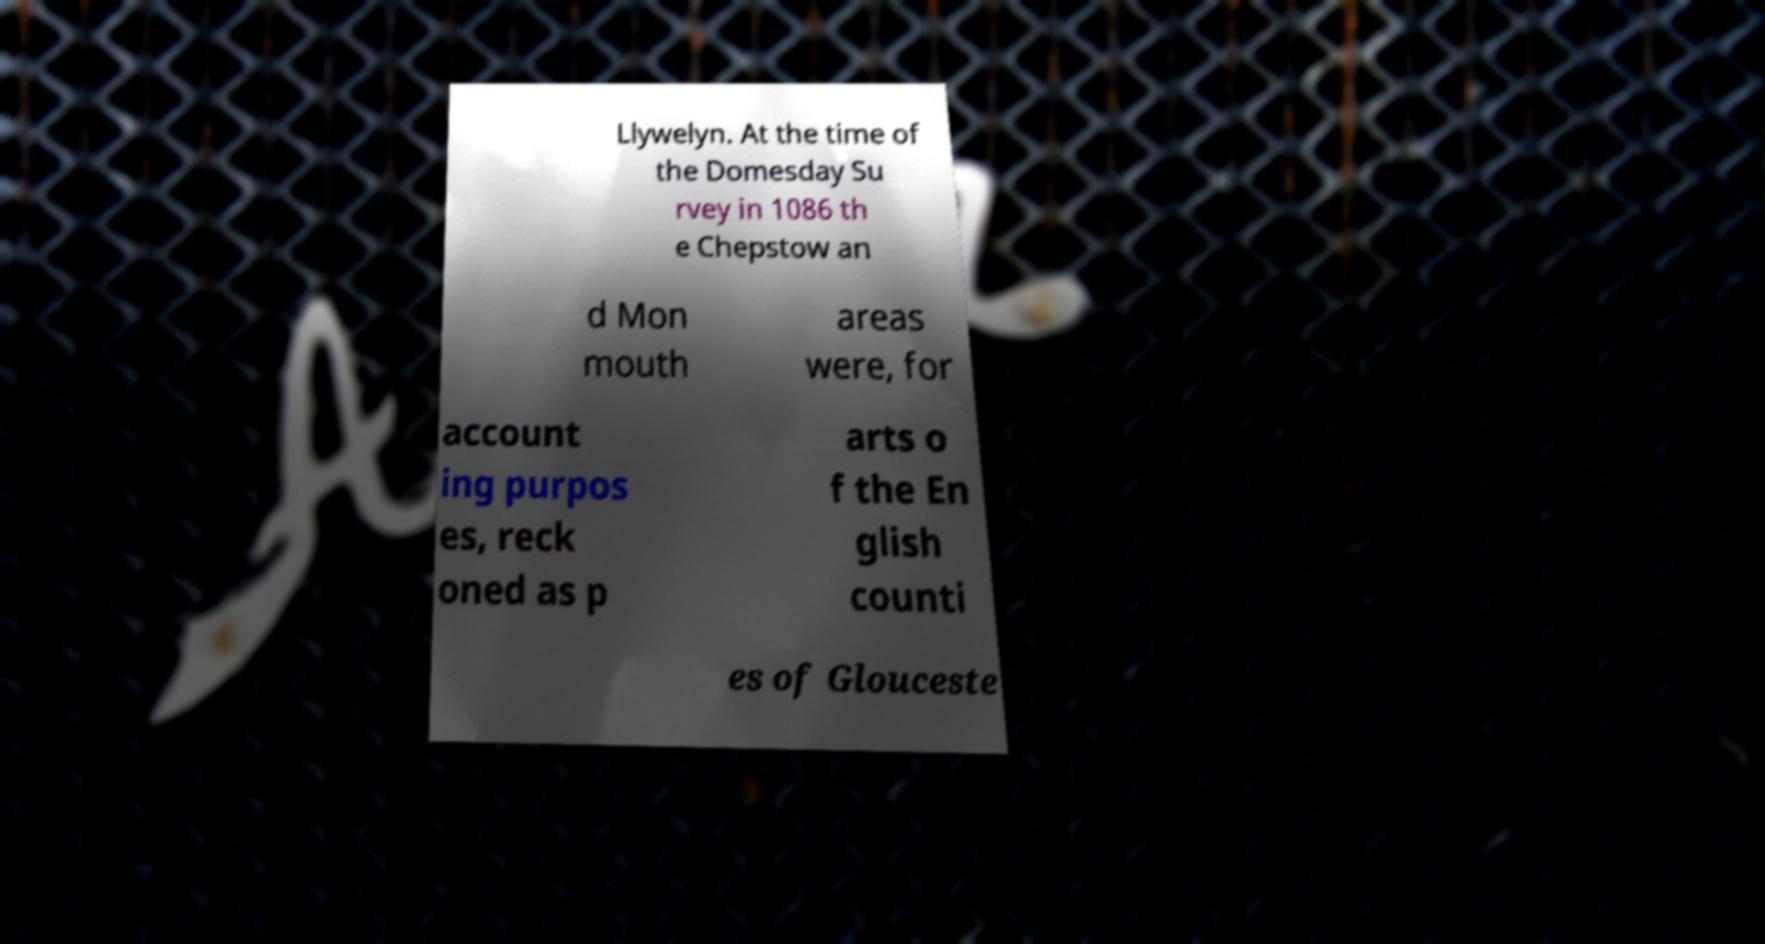There's text embedded in this image that I need extracted. Can you transcribe it verbatim? Llywelyn. At the time of the Domesday Su rvey in 1086 th e Chepstow an d Mon mouth areas were, for account ing purpos es, reck oned as p arts o f the En glish counti es of Glouceste 